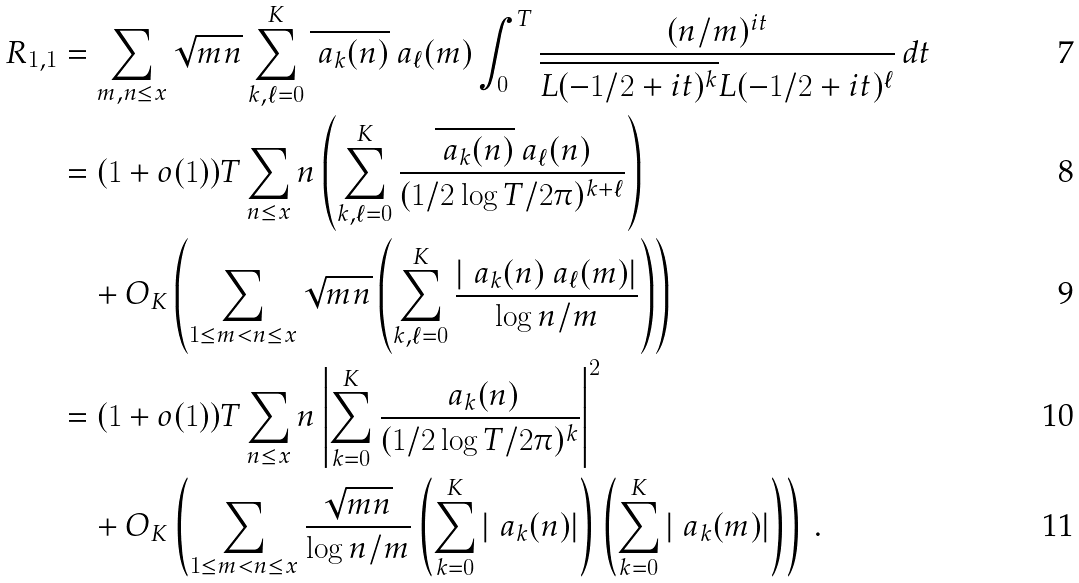<formula> <loc_0><loc_0><loc_500><loc_500>R _ { 1 , 1 } & = \sum _ { m , n \leq x } \sqrt { m n } \sum ^ { K } _ { k , \ell = 0 } \overline { \ a _ { k } ( n ) } \ a _ { \ell } ( m ) \int ^ { T } _ { 0 } \frac { ( n / m ) ^ { i t } } { \overline { L ( - 1 / 2 + i t ) ^ { k } } L ( - 1 / 2 + i t ) ^ { \ell } } \, d t \\ & = ( 1 + o ( 1 ) ) T \sum _ { n \leq x } n \left ( \sum ^ { K } _ { k , \ell = 0 } \frac { \overline { \ a _ { k } ( n ) } \ a _ { \ell } ( n ) } { ( 1 / 2 \log T / 2 \pi ) ^ { k + \ell } } \right ) \\ & \quad + O _ { K } \left ( \sum _ { 1 \leq m < n \leq x } \sqrt { m n } \left ( \sum ^ { K } _ { k , \ell = 0 } \frac { | \ a _ { k } ( n ) \ a _ { \ell } ( m ) | } { \log n / m } \right ) \right ) \\ & = ( 1 + o ( 1 ) ) T \sum _ { n \leq x } n \left | \sum ^ { K } _ { k = 0 } \frac { \ a _ { k } ( n ) } { ( 1 / 2 \log T / 2 \pi ) ^ { k } } \right | ^ { 2 } \\ & \quad + O _ { K } \left ( \sum _ { 1 \leq m < n \leq x } \frac { \sqrt { m n } } { \log n / m } \left ( \sum ^ { K } _ { k = 0 } | \ a _ { k } ( n ) | \right ) \left ( \sum ^ { K } _ { k = 0 } | \ a _ { k } ( m ) | \right ) \right ) \, .</formula> 